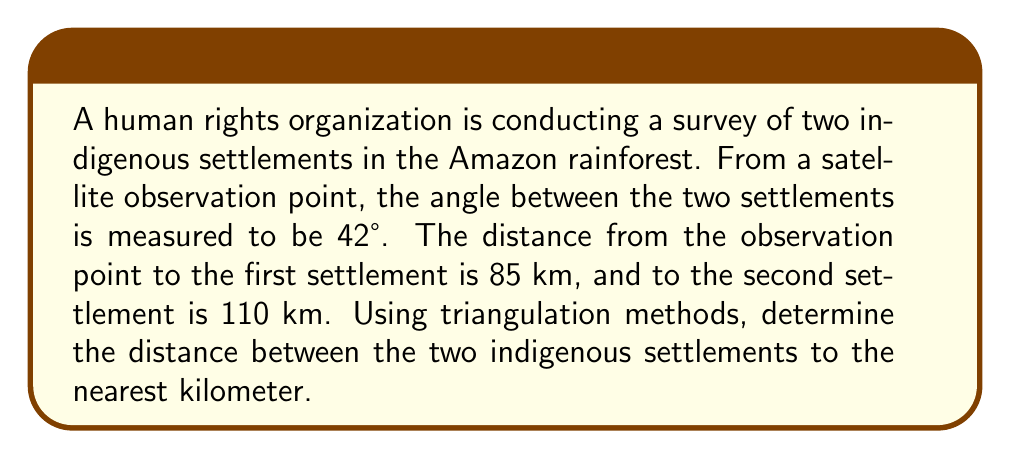Solve this math problem. To solve this problem, we'll use the law of cosines, which is ideal for triangulation when we know two sides and the included angle of a triangle.

Step 1: Identify the given information
- Angle between the settlements: $\theta = 42°$
- Distance to first settlement: $a = 85$ km
- Distance to second settlement: $b = 110$ km

Step 2: Set up the law of cosines formula
The law of cosines states: $c^2 = a^2 + b^2 - 2ab \cos(\theta)$
Where $c$ is the distance between the two settlements we're trying to find.

Step 3: Substitute the known values into the formula
$$c^2 = 85^2 + 110^2 - 2(85)(110)\cos(42°)$$

Step 4: Calculate the cosine of 42°
$\cos(42°) \approx 0.7431$

Step 5: Solve the equation
$$\begin{align*}
c^2 &= 85^2 + 110^2 - 2(85)(110)(0.7431) \\
&= 7,225 + 12,100 - 13,892.57 \\
&= 5,432.43
\end{align*}$$

Step 6: Take the square root to find c
$$c = \sqrt{5,432.43} \approx 73.71 \text{ km}$$

Step 7: Round to the nearest kilometer
$c \approx 74 \text{ km}$

Therefore, the distance between the two indigenous settlements is approximately 74 km.
Answer: 74 km 